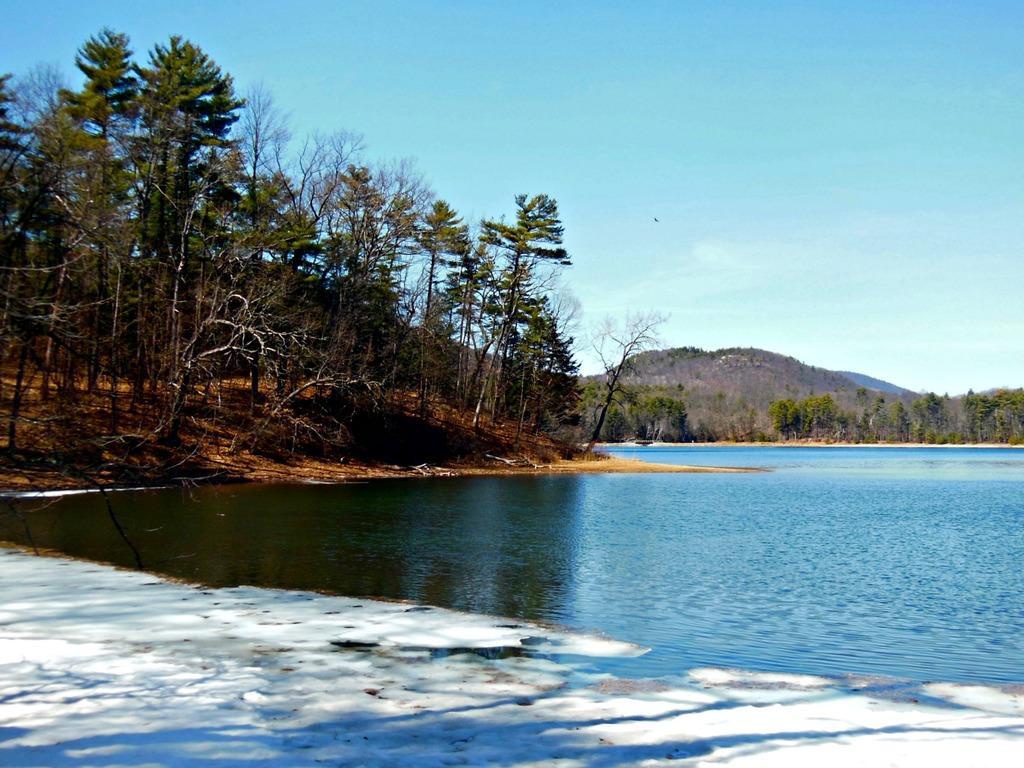How would you summarize this image in a sentence or two? In this picture I can see trees, hill and I can see water and a blue cloudy sky. 